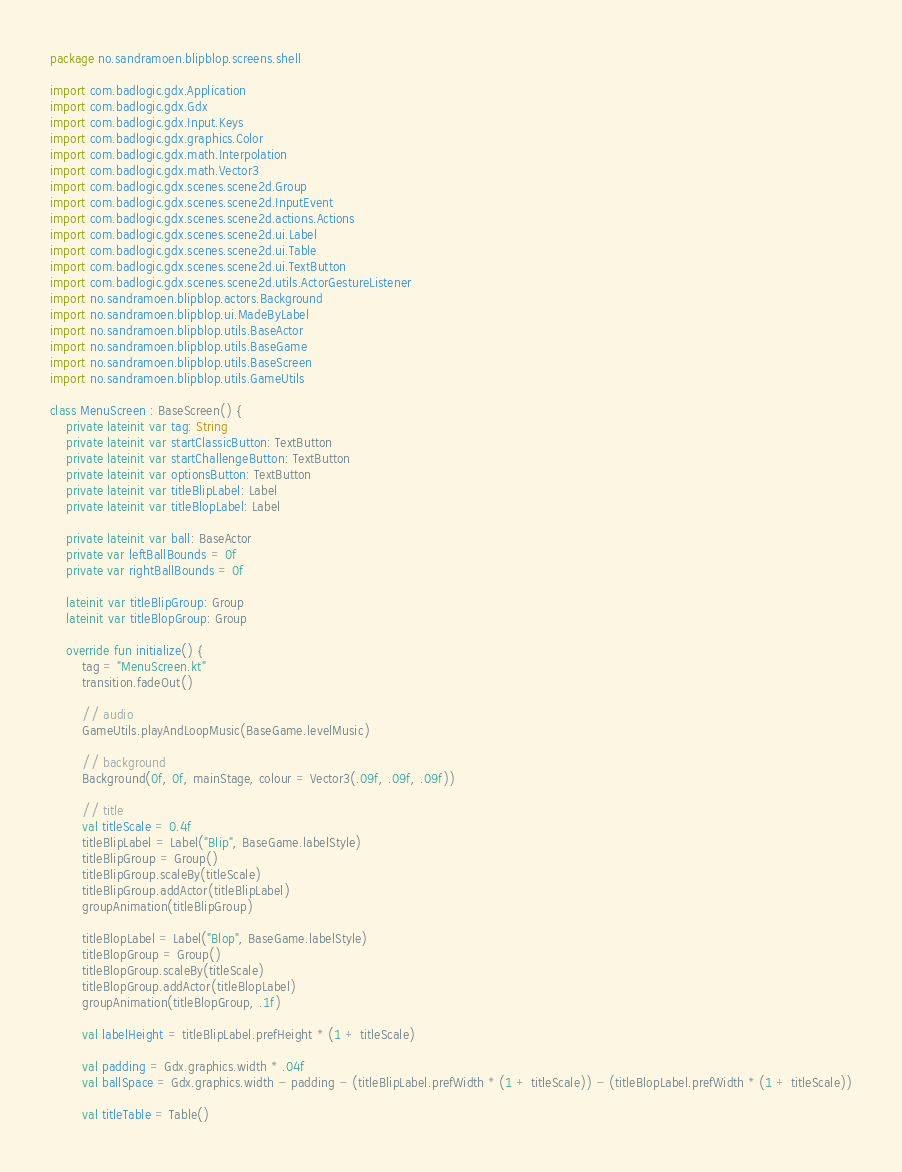Convert code to text. <code><loc_0><loc_0><loc_500><loc_500><_Kotlin_>package no.sandramoen.blipblop.screens.shell

import com.badlogic.gdx.Application
import com.badlogic.gdx.Gdx
import com.badlogic.gdx.Input.Keys
import com.badlogic.gdx.graphics.Color
import com.badlogic.gdx.math.Interpolation
import com.badlogic.gdx.math.Vector3
import com.badlogic.gdx.scenes.scene2d.Group
import com.badlogic.gdx.scenes.scene2d.InputEvent
import com.badlogic.gdx.scenes.scene2d.actions.Actions
import com.badlogic.gdx.scenes.scene2d.ui.Label
import com.badlogic.gdx.scenes.scene2d.ui.Table
import com.badlogic.gdx.scenes.scene2d.ui.TextButton
import com.badlogic.gdx.scenes.scene2d.utils.ActorGestureListener
import no.sandramoen.blipblop.actors.Background
import no.sandramoen.blipblop.ui.MadeByLabel
import no.sandramoen.blipblop.utils.BaseActor
import no.sandramoen.blipblop.utils.BaseGame
import no.sandramoen.blipblop.utils.BaseScreen
import no.sandramoen.blipblop.utils.GameUtils

class MenuScreen : BaseScreen() {
    private lateinit var tag: String
    private lateinit var startClassicButton: TextButton
    private lateinit var startChallengeButton: TextButton
    private lateinit var optionsButton: TextButton
    private lateinit var titleBlipLabel: Label
    private lateinit var titleBlopLabel: Label

    private lateinit var ball: BaseActor
    private var leftBallBounds = 0f
    private var rightBallBounds = 0f

    lateinit var titleBlipGroup: Group
    lateinit var titleBlopGroup: Group

    override fun initialize() {
        tag = "MenuScreen.kt"
        transition.fadeOut()

        // audio
        GameUtils.playAndLoopMusic(BaseGame.levelMusic)

        // background
        Background(0f, 0f, mainStage, colour = Vector3(.09f, .09f, .09f))

        // title
        val titleScale = 0.4f
        titleBlipLabel = Label("Blip", BaseGame.labelStyle)
        titleBlipGroup = Group()
        titleBlipGroup.scaleBy(titleScale)
        titleBlipGroup.addActor(titleBlipLabel)
        groupAnimation(titleBlipGroup)

        titleBlopLabel = Label("Blop", BaseGame.labelStyle)
        titleBlopGroup = Group()
        titleBlopGroup.scaleBy(titleScale)
        titleBlopGroup.addActor(titleBlopLabel)
        groupAnimation(titleBlopGroup, .1f)

        val labelHeight = titleBlipLabel.prefHeight * (1 + titleScale)

        val padding = Gdx.graphics.width * .04f
        val ballSpace = Gdx.graphics.width - padding - (titleBlipLabel.prefWidth * (1 + titleScale)) - (titleBlopLabel.prefWidth * (1 + titleScale))

        val titleTable = Table()</code> 